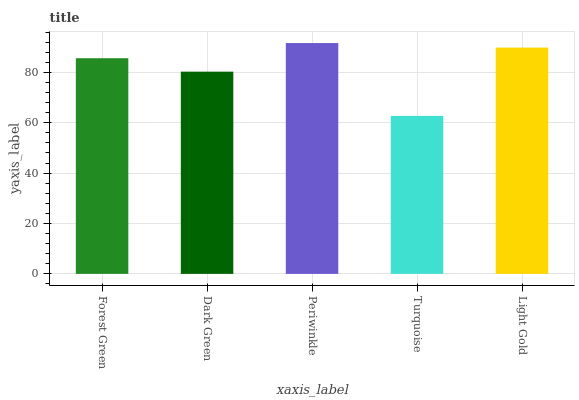Is Turquoise the minimum?
Answer yes or no. Yes. Is Periwinkle the maximum?
Answer yes or no. Yes. Is Dark Green the minimum?
Answer yes or no. No. Is Dark Green the maximum?
Answer yes or no. No. Is Forest Green greater than Dark Green?
Answer yes or no. Yes. Is Dark Green less than Forest Green?
Answer yes or no. Yes. Is Dark Green greater than Forest Green?
Answer yes or no. No. Is Forest Green less than Dark Green?
Answer yes or no. No. Is Forest Green the high median?
Answer yes or no. Yes. Is Forest Green the low median?
Answer yes or no. Yes. Is Turquoise the high median?
Answer yes or no. No. Is Dark Green the low median?
Answer yes or no. No. 